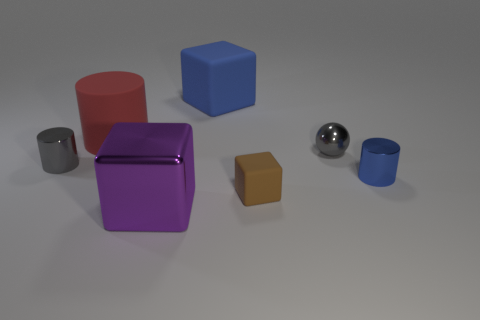Add 1 big blue things. How many objects exist? 8 Subtract all tiny cylinders. How many cylinders are left? 1 Subtract all cylinders. How many objects are left? 4 Add 2 brown things. How many brown things exist? 3 Subtract 0 cyan cylinders. How many objects are left? 7 Subtract all blue spheres. Subtract all blue blocks. How many spheres are left? 1 Subtract all purple metallic objects. Subtract all blue cylinders. How many objects are left? 5 Add 4 large purple blocks. How many large purple blocks are left? 5 